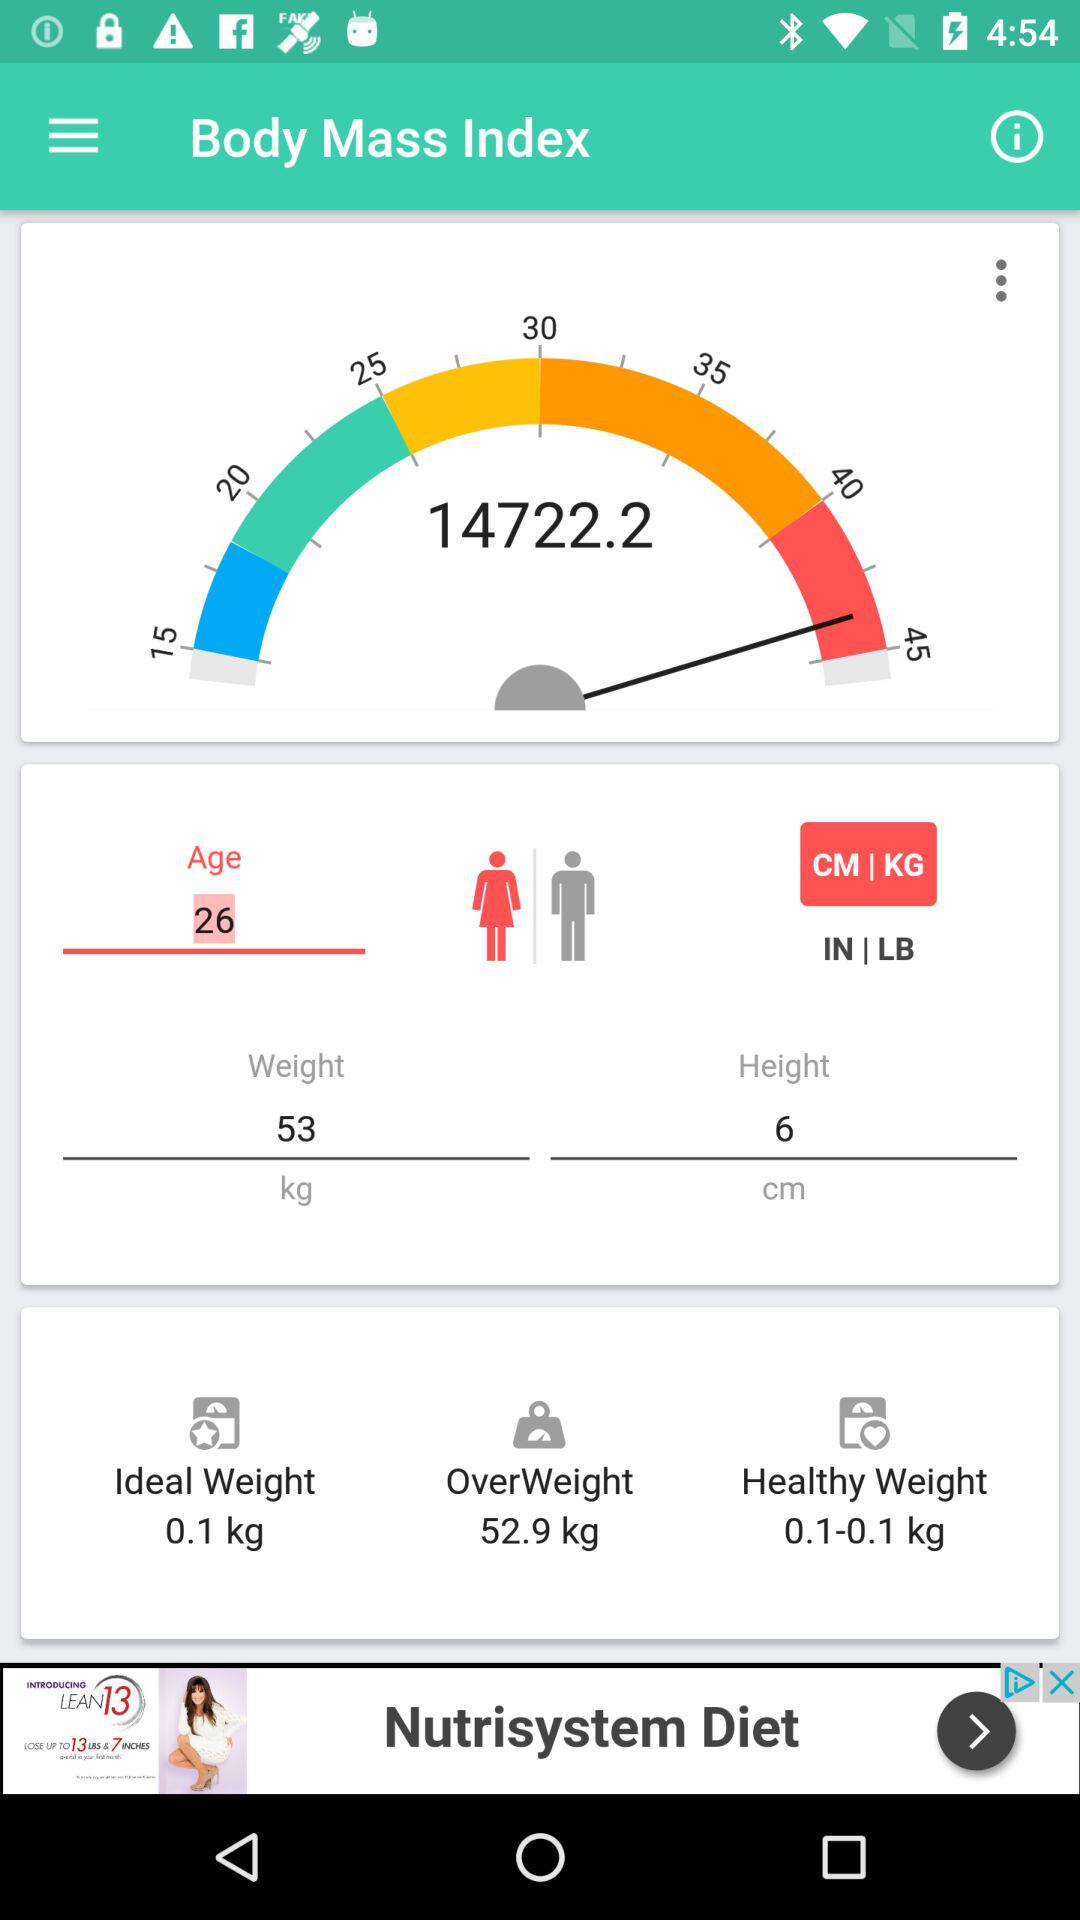What is the given weight? The given weight is 53 kg. 